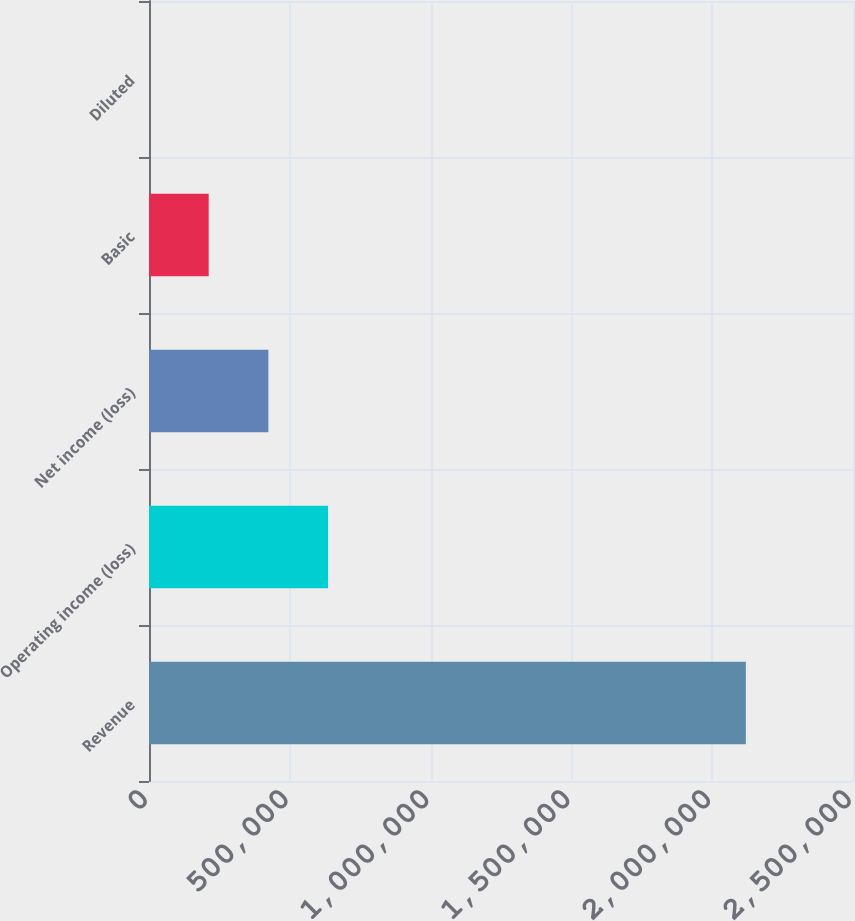Convert chart to OTSL. <chart><loc_0><loc_0><loc_500><loc_500><bar_chart><fcel>Revenue<fcel>Operating income (loss)<fcel>Net income (loss)<fcel>Basic<fcel>Diluted<nl><fcel>2.11946e+06<fcel>635837<fcel>423892<fcel>211946<fcel>0.65<nl></chart> 